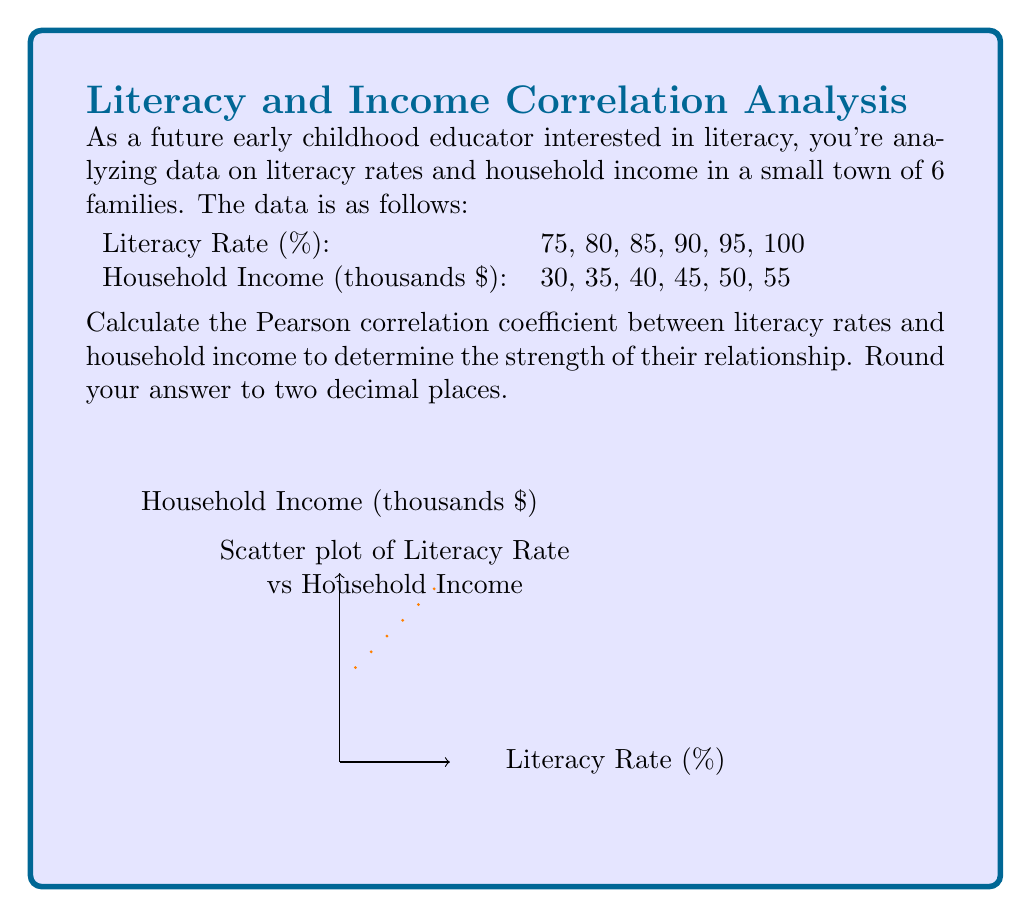Help me with this question. To calculate the Pearson correlation coefficient (r), we'll use the formula:

$$ r = \frac{n\sum xy - \sum x \sum y}{\sqrt{[n\sum x^2 - (\sum x)^2][n\sum y^2 - (\sum y)^2]}} $$

Where:
n = number of pairs of data
x = literacy rate
y = household income

Step 1: Calculate the necessary sums:
$\sum x = 75 + 80 + 85 + 90 + 95 + 100 = 525$
$\sum y = 30 + 35 + 40 + 45 + 50 + 55 = 255$
$\sum xy = (75)(30) + (80)(35) + (85)(40) + (90)(45) + (95)(50) + (100)(55) = 22,625$
$\sum x^2 = 75^2 + 80^2 + 85^2 + 90^2 + 95^2 + 100^2 = 46,225$
$\sum y^2 = 30^2 + 35^2 + 40^2 + 45^2 + 50^2 + 55^2 = 11,175$

Step 2: Substitute these values into the formula:

$$ r = \frac{6(22,625) - (525)(255)}{\sqrt{[6(46,225) - 525^2][6(11,175) - 255^2]}} $$

Step 3: Simplify:

$$ r = \frac{135,750 - 133,875}{\sqrt{(277,350 - 275,625)(67,050 - 65,025)}} $$

$$ r = \frac{1,875}{\sqrt{(1,725)(2,025)}} $$

$$ r = \frac{1,875}{\sqrt{3,493,125}} $$

$$ r = \frac{1,875}{1,868.99} $$

$$ r \approx 1.0032 $$

Step 4: Round to two decimal places:

$$ r \approx 1.00 $$

This indicates a perfect positive linear correlation between literacy rates and household income in this sample.
Answer: $1.00$ 